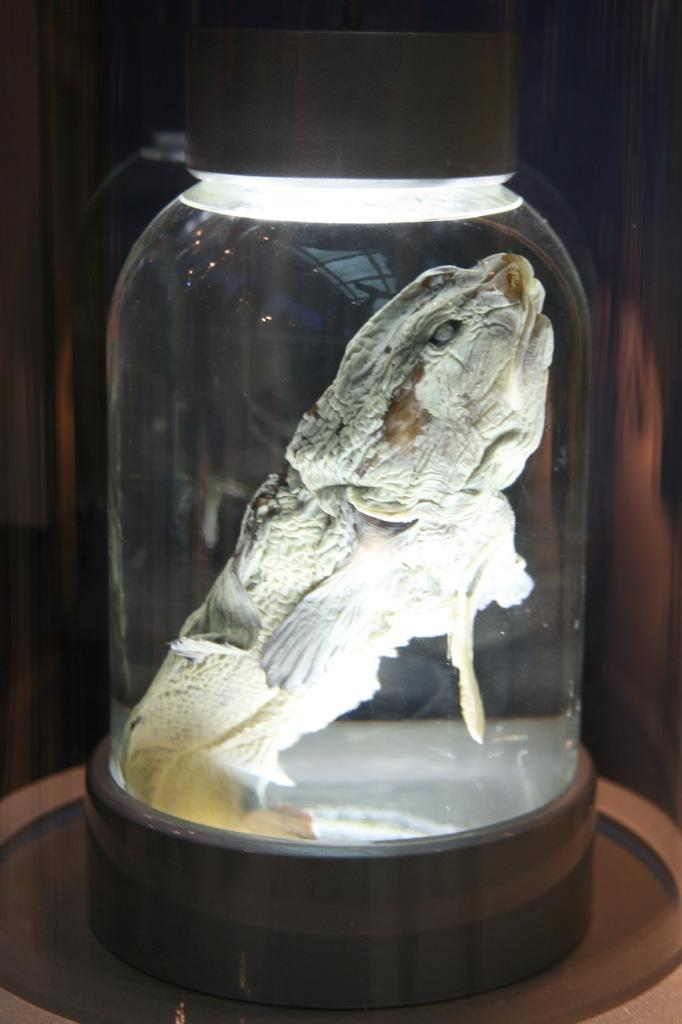What is the main object in the image? There is a table in the image. What is on the table? There is an animal in a bottle on the table. What can be seen in the background of the image? There is a wall visible in the background of the image. How many girls are wearing yak underwear in the image? There are no girls or yak underwear present in the image. 